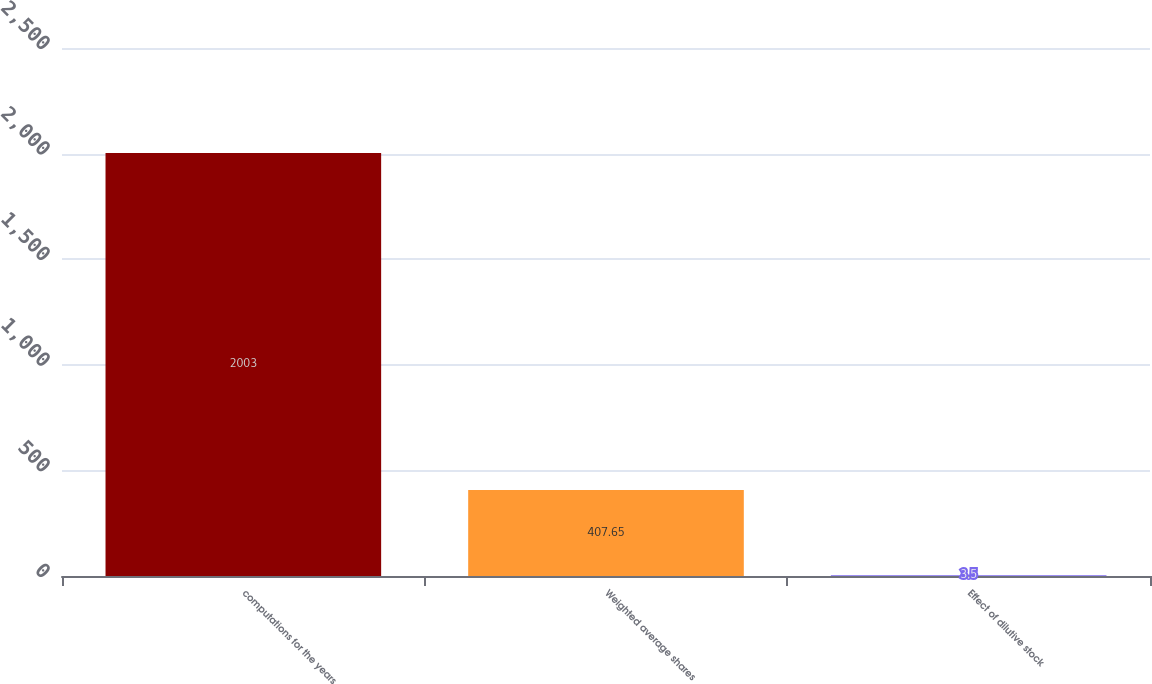Convert chart. <chart><loc_0><loc_0><loc_500><loc_500><bar_chart><fcel>computations for the years<fcel>Weighted average shares<fcel>Effect of dilutive stock<nl><fcel>2003<fcel>407.65<fcel>3.5<nl></chart> 